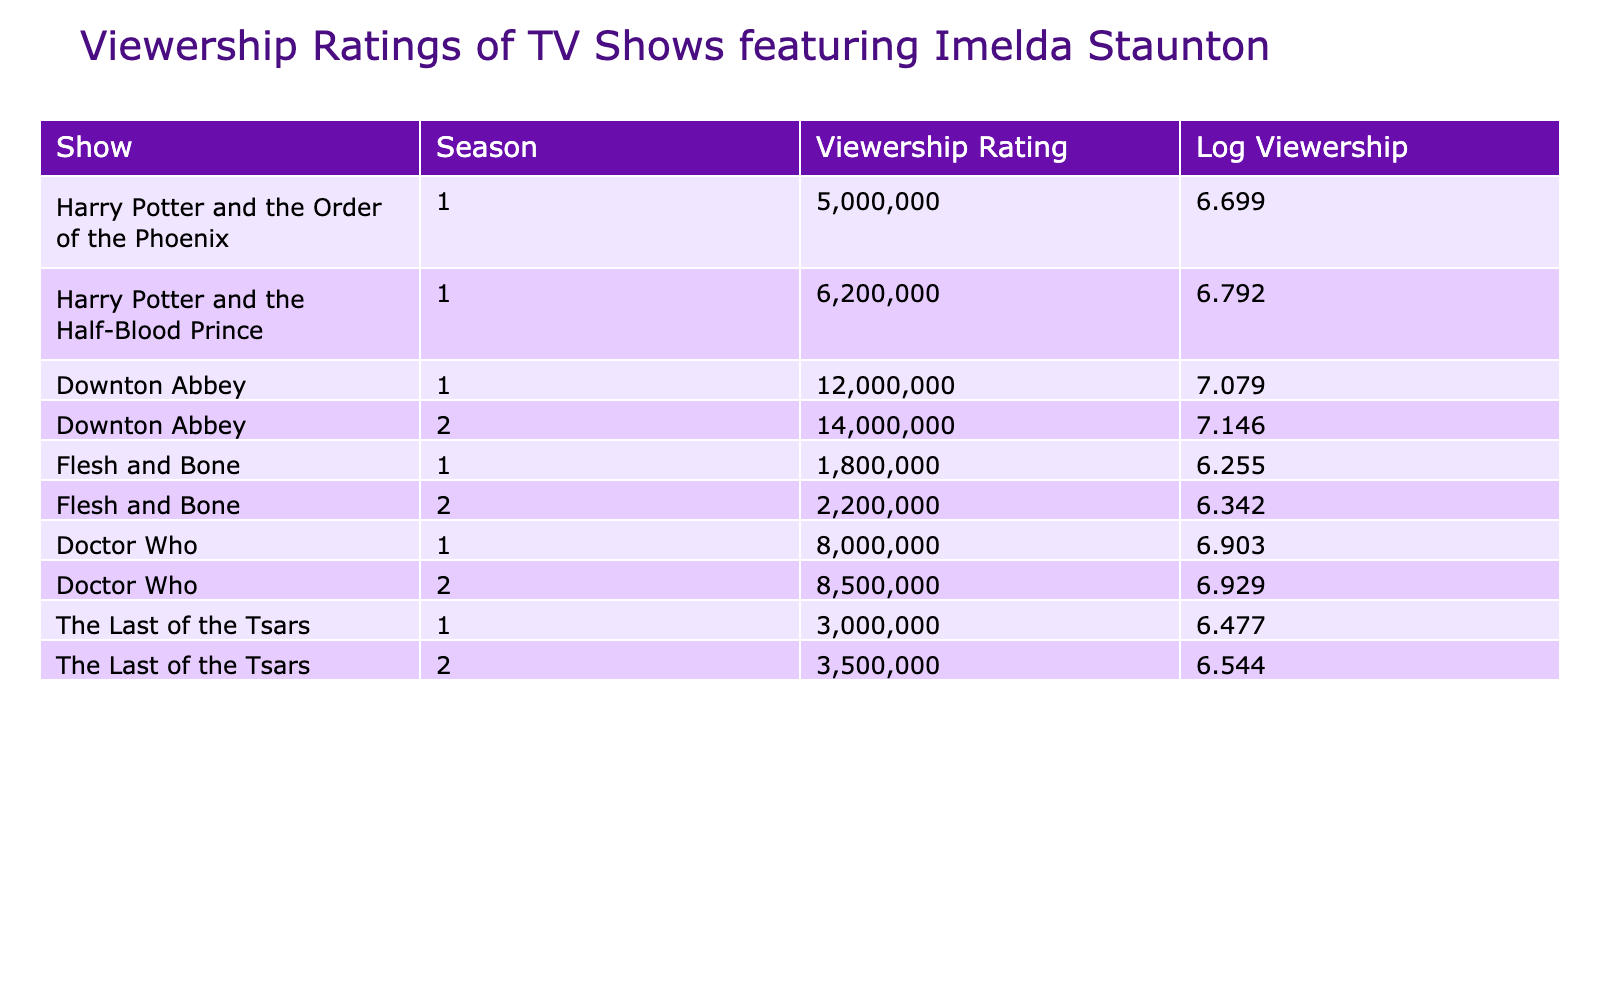What is the viewership rating for "Downton Abbey" in Season 1? The table states that for "Downton Abbey" in Season 1, the viewership rating is listed as 12000000.
Answer: 12000000 Which show has the highest viewership rating in the second season? Checking the second season ratings, "Downton Abbey" shows a rating of 14000000, which is higher than other shows. Therefore, it has the highest viewership rating.
Answer: 14000000 What is the average viewership rating for "Flesh and Bone" across both seasons? The total viewership for "Flesh and Bone" is 1800000 (Season 1) + 2200000 (Season 2) = 4000000. Since there are 2 seasons, the average is 4000000 / 2 = 2000000.
Answer: 2000000 Is the viewership rating for "Doctor Who" in Season 2 higher than 8000000? The table shows that the viewership rating for "Doctor Who" in Season 2 is 8500000, which is indeed higher than 8000000.
Answer: Yes What is the difference in viewership ratings between "Harry Potter and the Half-Blood Prince" and "The Last of the Tsars" in Season 1? In Season 1, "Harry Potter and the Half-Blood Prince" has a rating of 6200000, while "The Last of the Tsars" has a rating of 3000000. The difference is 6200000 - 3000000 = 3200000.
Answer: 3200000 Which season of "Flesh and Bone" has a lower viewership rating and what is that rating? "Flesh and Bone" Season 1 has a viewership rating of 1800000, while Season 2 has a rating of 2200000. Thus, Season 1 has the lower rating of 1800000.
Answer: 1800000 How many shows have a viewership rating greater than 8000000? Looking at the table, "Downton Abbey" (12000000 and 14000000) and "Doctor Who" (8000000 and 8500000) have ratings greater than 8000000. In total, there are 3 shows that meet this criterion.
Answer: 3 